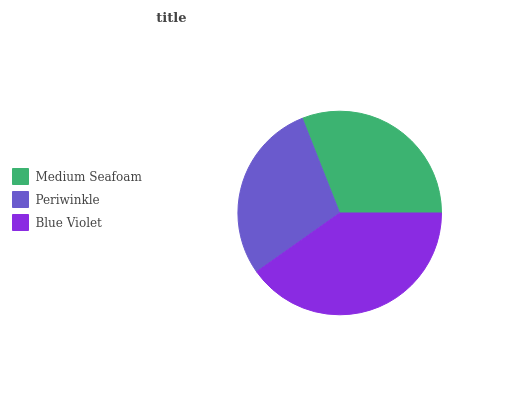Is Periwinkle the minimum?
Answer yes or no. Yes. Is Blue Violet the maximum?
Answer yes or no. Yes. Is Blue Violet the minimum?
Answer yes or no. No. Is Periwinkle the maximum?
Answer yes or no. No. Is Blue Violet greater than Periwinkle?
Answer yes or no. Yes. Is Periwinkle less than Blue Violet?
Answer yes or no. Yes. Is Periwinkle greater than Blue Violet?
Answer yes or no. No. Is Blue Violet less than Periwinkle?
Answer yes or no. No. Is Medium Seafoam the high median?
Answer yes or no. Yes. Is Medium Seafoam the low median?
Answer yes or no. Yes. Is Blue Violet the high median?
Answer yes or no. No. Is Periwinkle the low median?
Answer yes or no. No. 